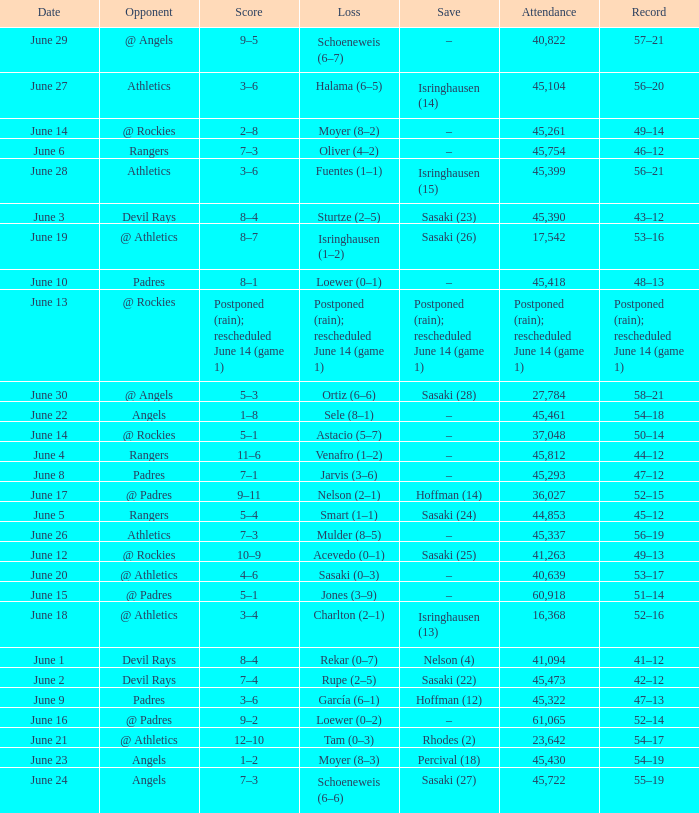What was the date of the Mariners game when they had a record of 53–17? June 20. 